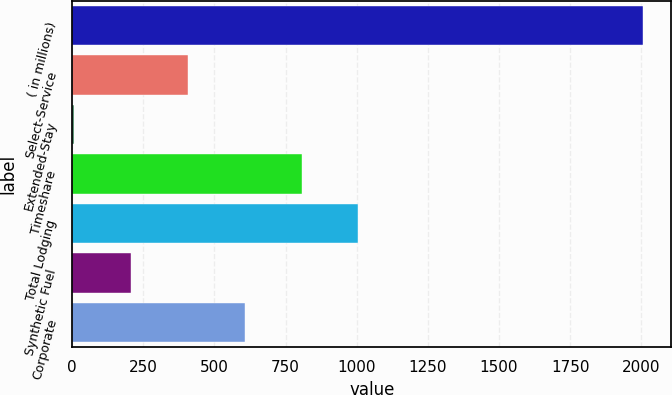Convert chart to OTSL. <chart><loc_0><loc_0><loc_500><loc_500><bar_chart><fcel>( in millions)<fcel>Select-Service<fcel>Extended-Stay<fcel>Timeshare<fcel>Total Lodging<fcel>Synthetic Fuel<fcel>Corporate<nl><fcel>2005<fcel>406.6<fcel>7<fcel>806.2<fcel>1006<fcel>206.8<fcel>606.4<nl></chart> 